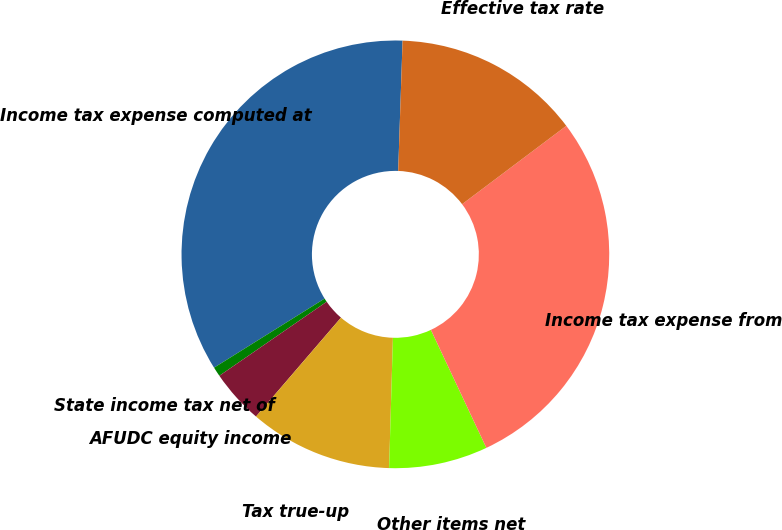Convert chart. <chart><loc_0><loc_0><loc_500><loc_500><pie_chart><fcel>Income tax expense computed at<fcel>State income tax net of<fcel>AFUDC equity income<fcel>Tax true-up<fcel>Other items net<fcel>Income tax expense from<fcel>Effective tax rate<nl><fcel>34.42%<fcel>0.72%<fcel>4.09%<fcel>10.83%<fcel>7.46%<fcel>28.26%<fcel>14.2%<nl></chart> 